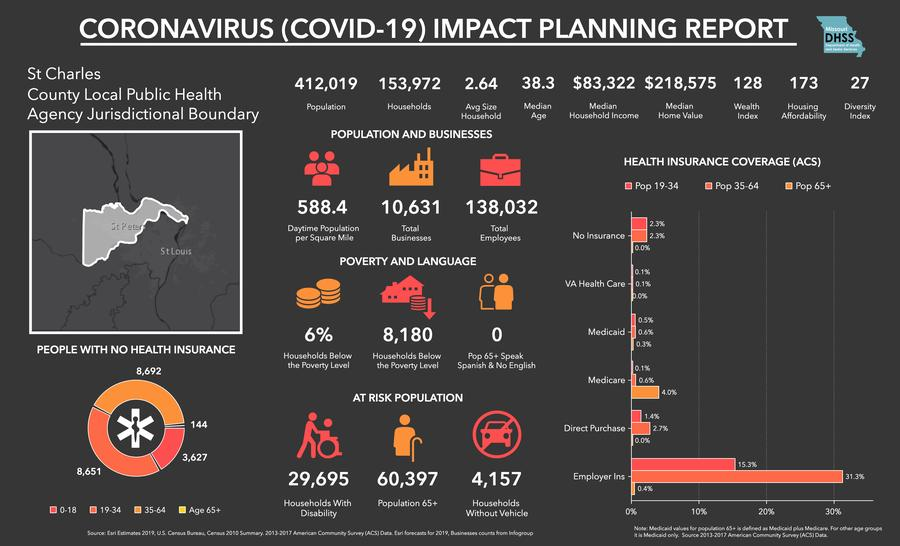Mention a couple of crucial points in this snapshot. The age group with the highest number of people without health insurance is 35-64. According to recent data, only 4.0% of senior citizens have Medicare coverage. In the county, there are a total of 10,631 businesses. The total population of St. Charles County is 412,019. According to the data, approximately 6% of households are below the poverty line. 